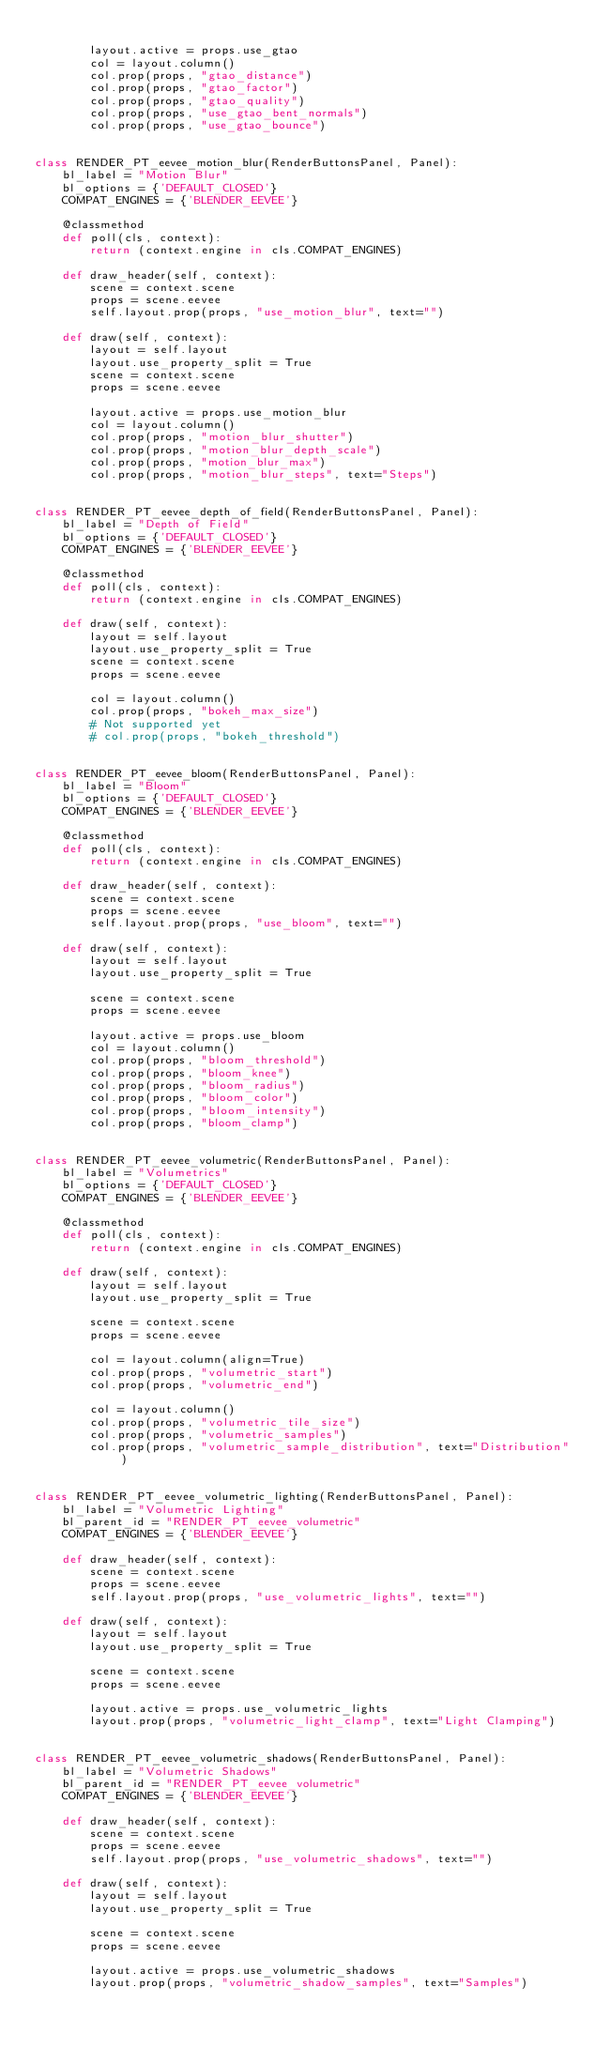<code> <loc_0><loc_0><loc_500><loc_500><_Python_>
        layout.active = props.use_gtao
        col = layout.column()
        col.prop(props, "gtao_distance")
        col.prop(props, "gtao_factor")
        col.prop(props, "gtao_quality")
        col.prop(props, "use_gtao_bent_normals")
        col.prop(props, "use_gtao_bounce")


class RENDER_PT_eevee_motion_blur(RenderButtonsPanel, Panel):
    bl_label = "Motion Blur"
    bl_options = {'DEFAULT_CLOSED'}
    COMPAT_ENGINES = {'BLENDER_EEVEE'}

    @classmethod
    def poll(cls, context):
        return (context.engine in cls.COMPAT_ENGINES)

    def draw_header(self, context):
        scene = context.scene
        props = scene.eevee
        self.layout.prop(props, "use_motion_blur", text="")

    def draw(self, context):
        layout = self.layout
        layout.use_property_split = True
        scene = context.scene
        props = scene.eevee

        layout.active = props.use_motion_blur
        col = layout.column()
        col.prop(props, "motion_blur_shutter")
        col.prop(props, "motion_blur_depth_scale")
        col.prop(props, "motion_blur_max")
        col.prop(props, "motion_blur_steps", text="Steps")


class RENDER_PT_eevee_depth_of_field(RenderButtonsPanel, Panel):
    bl_label = "Depth of Field"
    bl_options = {'DEFAULT_CLOSED'}
    COMPAT_ENGINES = {'BLENDER_EEVEE'}

    @classmethod
    def poll(cls, context):
        return (context.engine in cls.COMPAT_ENGINES)

    def draw(self, context):
        layout = self.layout
        layout.use_property_split = True
        scene = context.scene
        props = scene.eevee

        col = layout.column()
        col.prop(props, "bokeh_max_size")
        # Not supported yet
        # col.prop(props, "bokeh_threshold")


class RENDER_PT_eevee_bloom(RenderButtonsPanel, Panel):
    bl_label = "Bloom"
    bl_options = {'DEFAULT_CLOSED'}
    COMPAT_ENGINES = {'BLENDER_EEVEE'}

    @classmethod
    def poll(cls, context):
        return (context.engine in cls.COMPAT_ENGINES)

    def draw_header(self, context):
        scene = context.scene
        props = scene.eevee
        self.layout.prop(props, "use_bloom", text="")

    def draw(self, context):
        layout = self.layout
        layout.use_property_split = True

        scene = context.scene
        props = scene.eevee

        layout.active = props.use_bloom
        col = layout.column()
        col.prop(props, "bloom_threshold")
        col.prop(props, "bloom_knee")
        col.prop(props, "bloom_radius")
        col.prop(props, "bloom_color")
        col.prop(props, "bloom_intensity")
        col.prop(props, "bloom_clamp")


class RENDER_PT_eevee_volumetric(RenderButtonsPanel, Panel):
    bl_label = "Volumetrics"
    bl_options = {'DEFAULT_CLOSED'}
    COMPAT_ENGINES = {'BLENDER_EEVEE'}

    @classmethod
    def poll(cls, context):
        return (context.engine in cls.COMPAT_ENGINES)

    def draw(self, context):
        layout = self.layout
        layout.use_property_split = True

        scene = context.scene
        props = scene.eevee

        col = layout.column(align=True)
        col.prop(props, "volumetric_start")
        col.prop(props, "volumetric_end")

        col = layout.column()
        col.prop(props, "volumetric_tile_size")
        col.prop(props, "volumetric_samples")
        col.prop(props, "volumetric_sample_distribution", text="Distribution")


class RENDER_PT_eevee_volumetric_lighting(RenderButtonsPanel, Panel):
    bl_label = "Volumetric Lighting"
    bl_parent_id = "RENDER_PT_eevee_volumetric"
    COMPAT_ENGINES = {'BLENDER_EEVEE'}

    def draw_header(self, context):
        scene = context.scene
        props = scene.eevee
        self.layout.prop(props, "use_volumetric_lights", text="")

    def draw(self, context):
        layout = self.layout
        layout.use_property_split = True

        scene = context.scene
        props = scene.eevee

        layout.active = props.use_volumetric_lights
        layout.prop(props, "volumetric_light_clamp", text="Light Clamping")


class RENDER_PT_eevee_volumetric_shadows(RenderButtonsPanel, Panel):
    bl_label = "Volumetric Shadows"
    bl_parent_id = "RENDER_PT_eevee_volumetric"
    COMPAT_ENGINES = {'BLENDER_EEVEE'}

    def draw_header(self, context):
        scene = context.scene
        props = scene.eevee
        self.layout.prop(props, "use_volumetric_shadows", text="")

    def draw(self, context):
        layout = self.layout
        layout.use_property_split = True

        scene = context.scene
        props = scene.eevee

        layout.active = props.use_volumetric_shadows
        layout.prop(props, "volumetric_shadow_samples", text="Samples")

</code> 